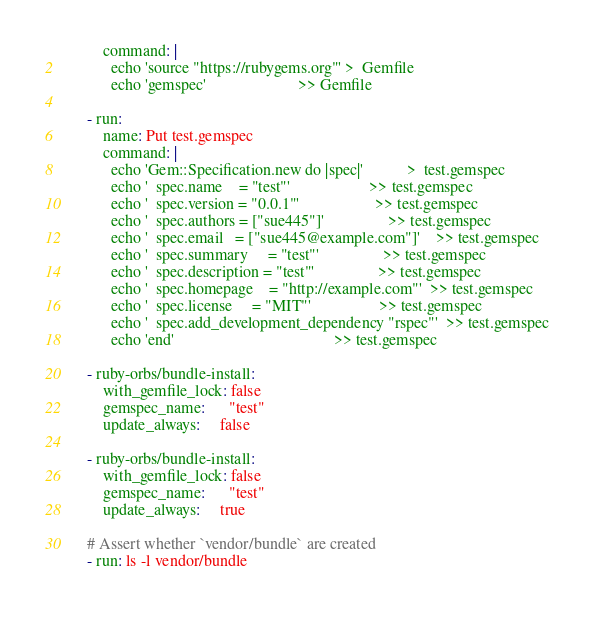<code> <loc_0><loc_0><loc_500><loc_500><_YAML_>          command: |
            echo 'source "https://rubygems.org"' >  Gemfile
            echo 'gemspec'                       >> Gemfile

      - run:
          name: Put test.gemspec
          command: |
            echo 'Gem::Specification.new do |spec|'           >  test.gemspec
            echo '  spec.name    = "test"'                    >> test.gemspec
            echo '  spec.version = "0.0.1"'                   >> test.gemspec
            echo '  spec.authors = ["sue445"]'                >> test.gemspec
            echo '  spec.email   = ["sue445@example.com"]'    >> test.gemspec
            echo '  spec.summary     = "test"'                >> test.gemspec
            echo '  spec.description = "test"'                >> test.gemspec
            echo '  spec.homepage    = "http://example.com"'  >> test.gemspec
            echo '  spec.license     = "MIT"'                 >> test.gemspec
            echo '  spec.add_development_dependency "rspec"'  >> test.gemspec
            echo 'end'                                        >> test.gemspec

      - ruby-orbs/bundle-install:
          with_gemfile_lock: false
          gemspec_name:      "test"
          update_always:     false

      - ruby-orbs/bundle-install:
          with_gemfile_lock: false
          gemspec_name:      "test"
          update_always:     true

      # Assert whether `vendor/bundle` are created
      - run: ls -l vendor/bundle
</code> 